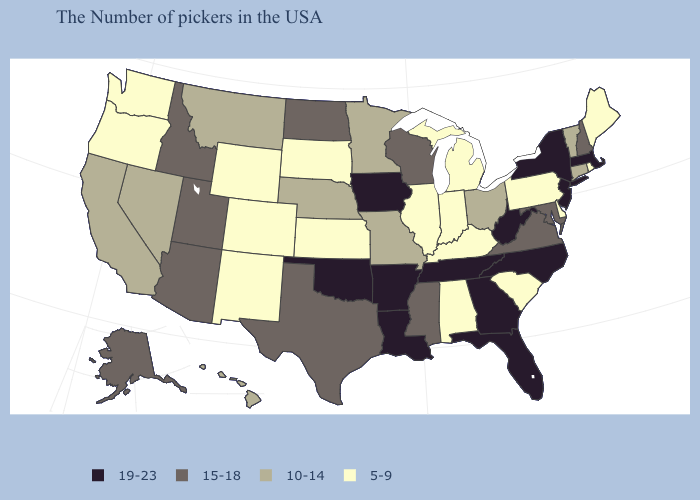What is the lowest value in states that border New Hampshire?
Concise answer only. 5-9. Does Alaska have the highest value in the West?
Be succinct. Yes. Is the legend a continuous bar?
Quick response, please. No. What is the value of Florida?
Give a very brief answer. 19-23. What is the value of Alaska?
Keep it brief. 15-18. Does the map have missing data?
Give a very brief answer. No. What is the lowest value in the USA?
Give a very brief answer. 5-9. What is the lowest value in the South?
Concise answer only. 5-9. Among the states that border Mississippi , which have the highest value?
Be succinct. Tennessee, Louisiana, Arkansas. What is the lowest value in states that border Iowa?
Short answer required. 5-9. What is the value of Arizona?
Concise answer only. 15-18. How many symbols are there in the legend?
Short answer required. 4. What is the lowest value in the South?
Short answer required. 5-9. Which states have the lowest value in the USA?
Short answer required. Maine, Rhode Island, Delaware, Pennsylvania, South Carolina, Michigan, Kentucky, Indiana, Alabama, Illinois, Kansas, South Dakota, Wyoming, Colorado, New Mexico, Washington, Oregon. Which states have the lowest value in the USA?
Concise answer only. Maine, Rhode Island, Delaware, Pennsylvania, South Carolina, Michigan, Kentucky, Indiana, Alabama, Illinois, Kansas, South Dakota, Wyoming, Colorado, New Mexico, Washington, Oregon. 